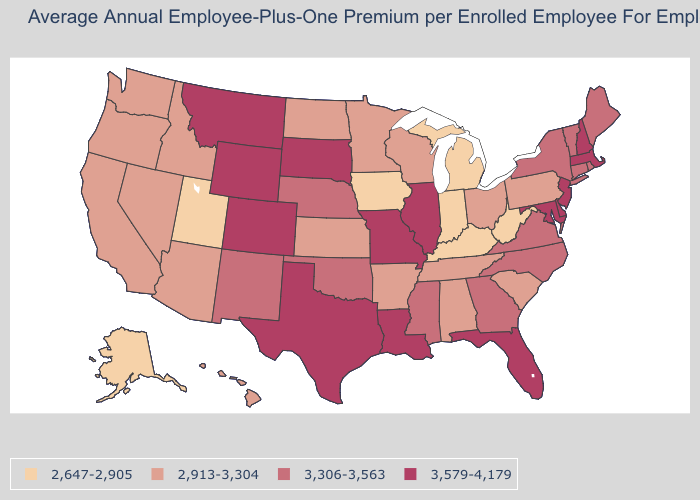How many symbols are there in the legend?
Short answer required. 4. What is the lowest value in states that border Massachusetts?
Short answer required. 3,306-3,563. What is the highest value in states that border North Carolina?
Quick response, please. 3,306-3,563. What is the value of North Carolina?
Concise answer only. 3,306-3,563. Name the states that have a value in the range 3,579-4,179?
Short answer required. Colorado, Delaware, Florida, Illinois, Louisiana, Maryland, Massachusetts, Missouri, Montana, New Hampshire, New Jersey, South Dakota, Texas, Wyoming. How many symbols are there in the legend?
Answer briefly. 4. What is the lowest value in the South?
Answer briefly. 2,647-2,905. What is the highest value in states that border Montana?
Be succinct. 3,579-4,179. Does the map have missing data?
Short answer required. No. What is the value of Illinois?
Give a very brief answer. 3,579-4,179. Name the states that have a value in the range 3,306-3,563?
Give a very brief answer. Connecticut, Georgia, Maine, Mississippi, Nebraska, New Mexico, New York, North Carolina, Oklahoma, Rhode Island, Vermont, Virginia. Does Pennsylvania have the same value as Ohio?
Concise answer only. Yes. Name the states that have a value in the range 2,913-3,304?
Keep it brief. Alabama, Arizona, Arkansas, California, Hawaii, Idaho, Kansas, Minnesota, Nevada, North Dakota, Ohio, Oregon, Pennsylvania, South Carolina, Tennessee, Washington, Wisconsin. Name the states that have a value in the range 3,579-4,179?
Write a very short answer. Colorado, Delaware, Florida, Illinois, Louisiana, Maryland, Massachusetts, Missouri, Montana, New Hampshire, New Jersey, South Dakota, Texas, Wyoming. Does Montana have a lower value than Texas?
Give a very brief answer. No. 